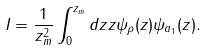<formula> <loc_0><loc_0><loc_500><loc_500>I = \frac { 1 } { z _ { m } ^ { 2 } } \int _ { 0 } ^ { z _ { m } } d z z \psi _ { \rho } ( z ) \psi _ { a _ { 1 } } ( z ) .</formula> 